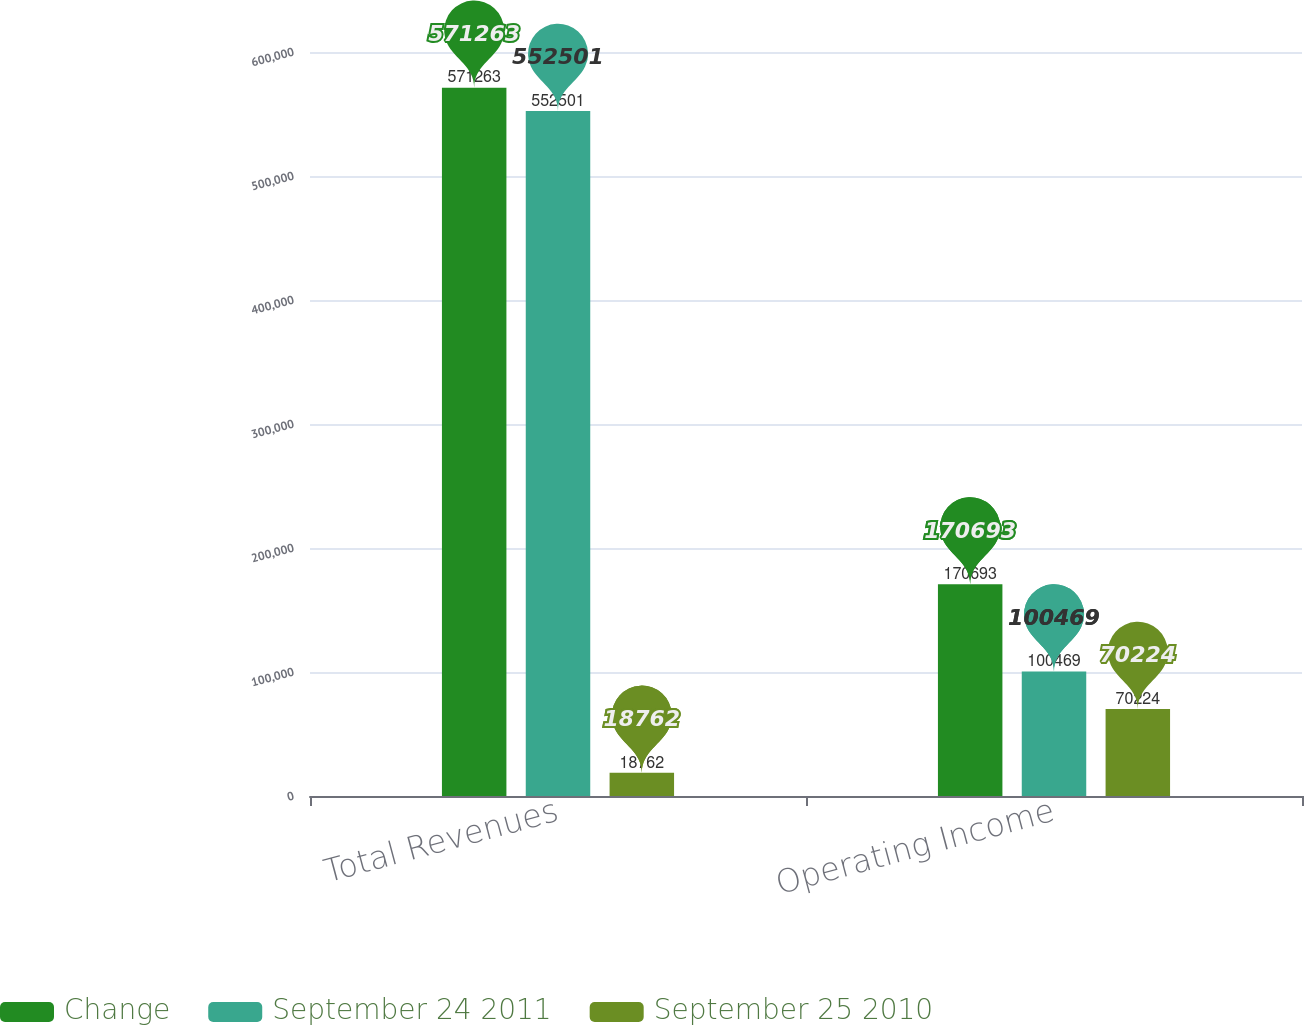<chart> <loc_0><loc_0><loc_500><loc_500><stacked_bar_chart><ecel><fcel>Total Revenues<fcel>Operating Income<nl><fcel>Change<fcel>571263<fcel>170693<nl><fcel>September 24 2011<fcel>552501<fcel>100469<nl><fcel>September 25 2010<fcel>18762<fcel>70224<nl></chart> 